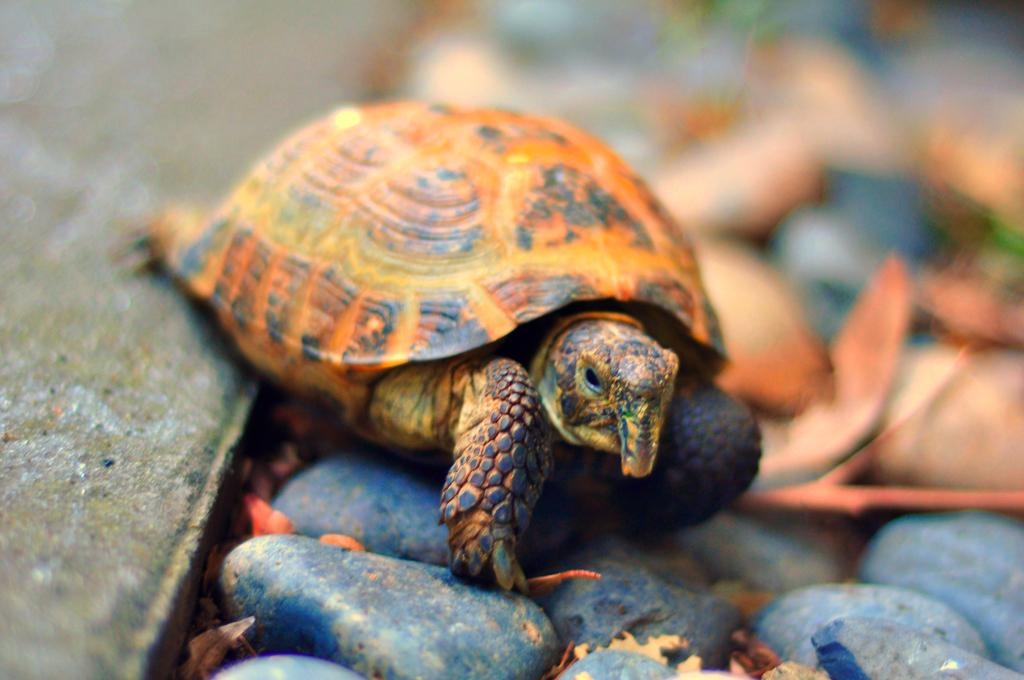What type of animal is in the image? There is a tortoise in the image. What else can be seen in the image besides the tortoise? There are stones in the image. Can you describe the background of the image? The background of the image is blurred. What is the taste of the sidewalk in the image? There is no sidewalk present in the image, so it is not possible to determine its taste. 